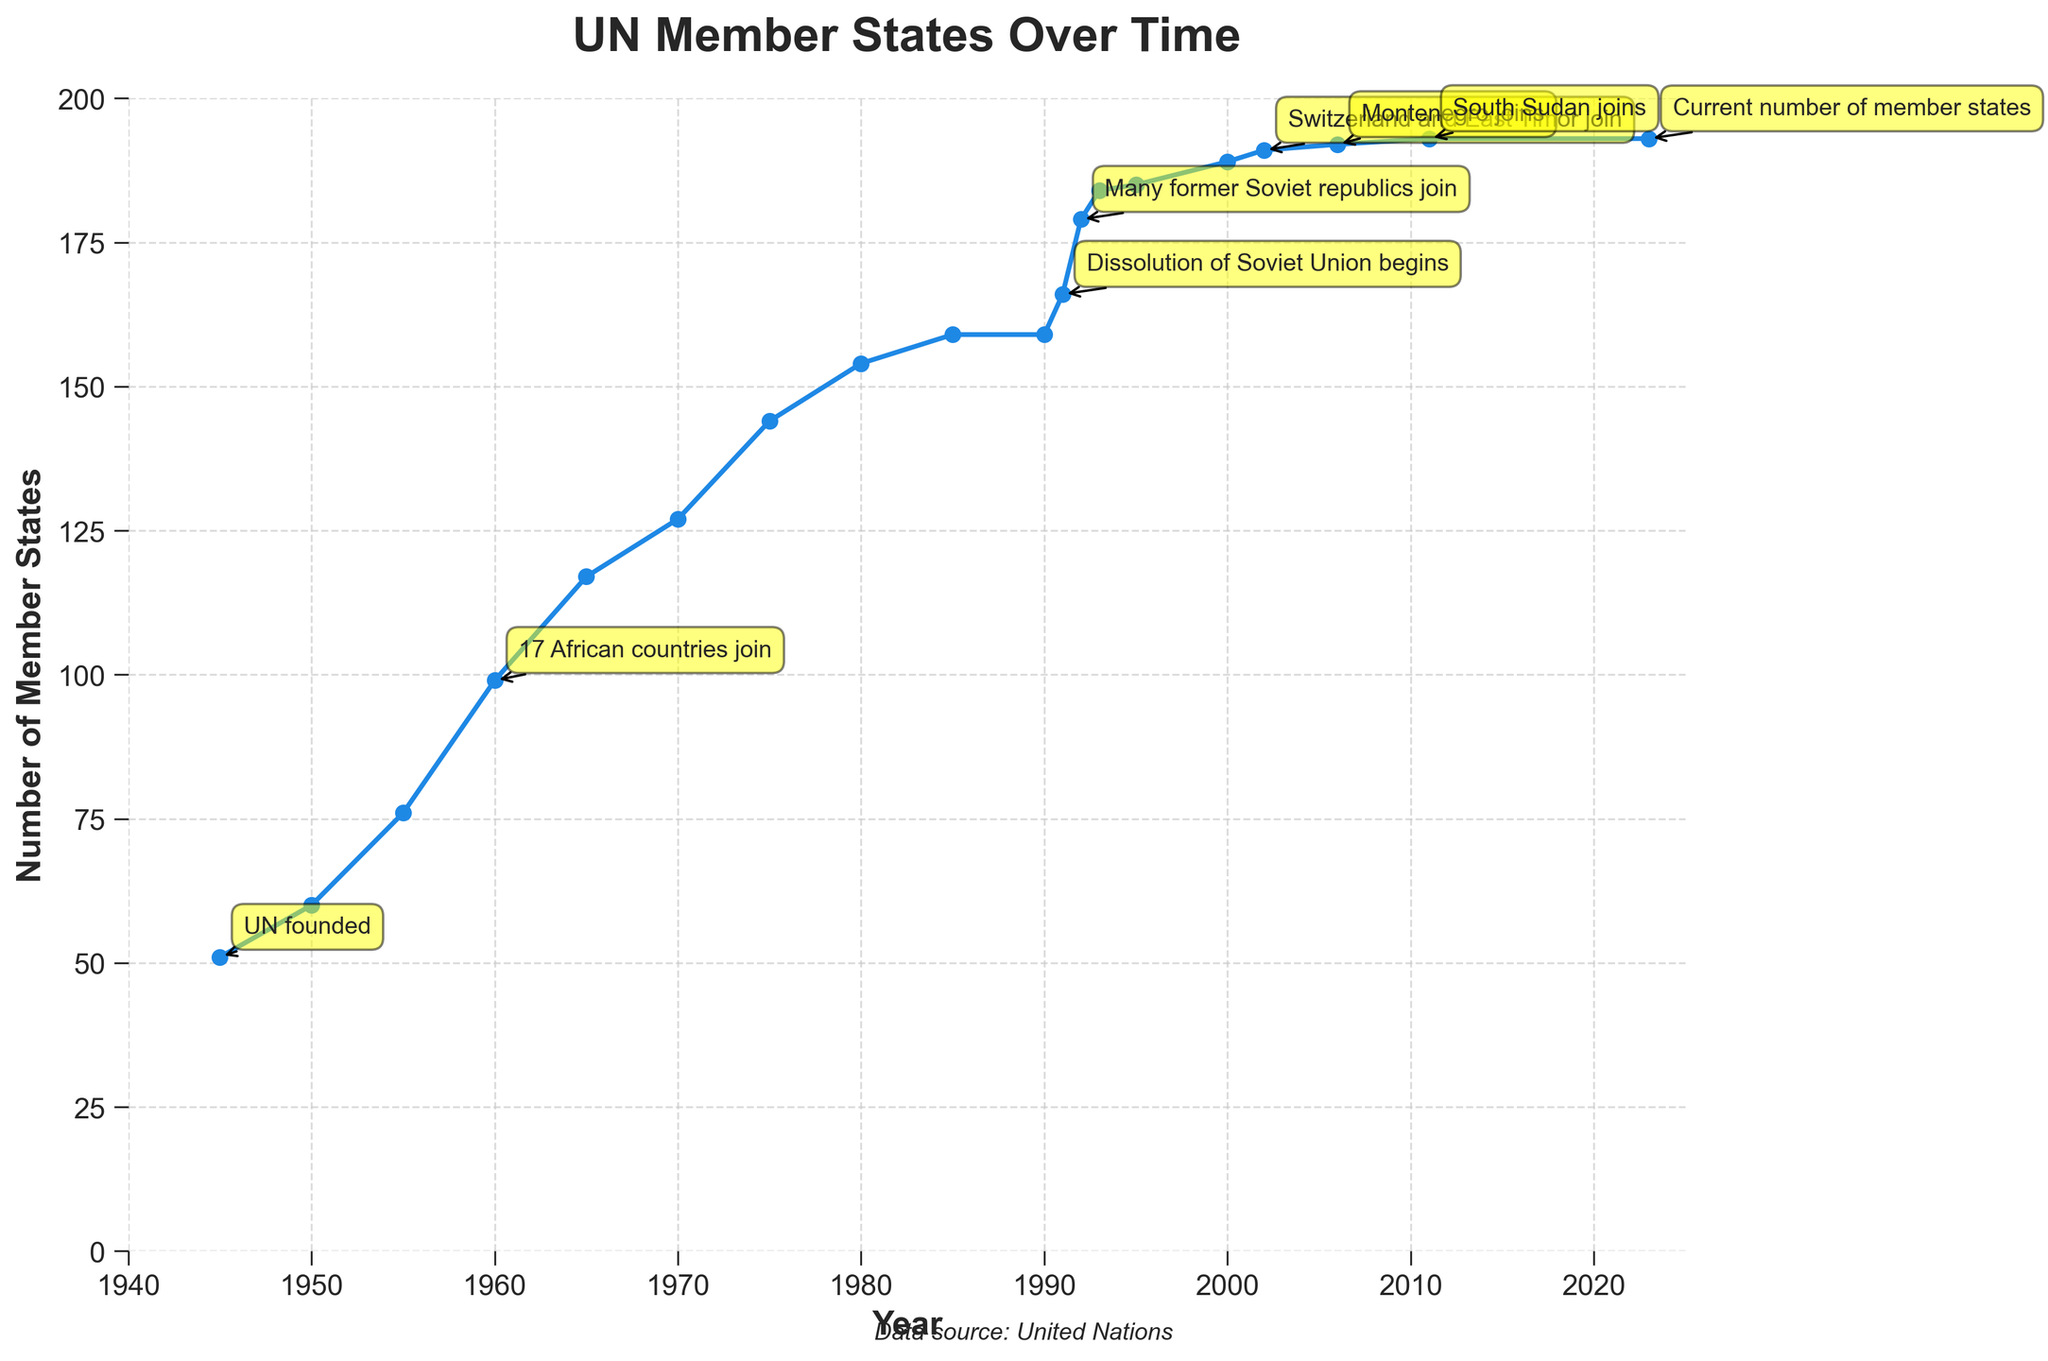In which year did the UN experience a significant increase in the number of member states, and what was the reason? Identify the event annotations on the graph. The largest noted increase is in 1960 due to 17 African countries joining.
Answer: 1960, 17 African countries join How many new member states joined the UN between 1990 and 1992? Locate the number of member states in 1990 (159) and 1992 (179). Subtract the two numbers: 179 - 159 = 20.
Answer: 20 Compare the number of member states in 1945 and 1960. How many more countries had joined by 1960? Identify the member states in 1945 (51) and in 1960 (99). Subtract the 1945 value from the 1960 value: 99 - 51 = 48.
Answer: 48 What was the number of member states after the dissolution of the Soviet Union began in 1991? Check the annotation for this event in 1991, which shows the number of member states as 166.
Answer: 166 Which event led to the UN gaining new member states in 2002, and how many were added that year? Check the annotation for 2002, which notes Switzerland and East Timor joining. The number of member states increased from 189 in 2000 to 191 in 2002. That is an addition of 2.
Answer: Switzerland and East Timor joined, 2 new member states In what year did South Sudan join the UN, and what was the total number of member states after its addition? Refer to the annotation in 2011 mentioning South Sudan and check the corresponding number of member states: 193.
Answer: 2011, 193 What is the current number of UN member states as of 2023? Check the number marked in 2023, which shows the current number of member states as 193.
Answer: 193 Between which years did the UN membership stay constant and at what number? Look for years with the same number of member states and identify the span. From 1985 (159 member states) to 1990 (159 member states), there was no change.
Answer: Between 1985 and 1990, 159 member states How did the number of member states change from 1950 to 1955? Identify the number of member states in 1950 (60) and 1955 (76). Calculate the difference: 76 - 60 = 16.
Answer: Increased by 16 